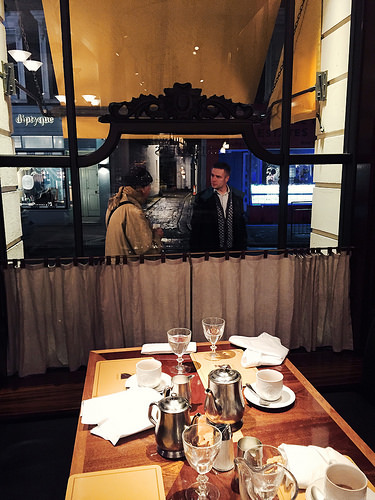<image>
Is the glass behind the teapot? Yes. From this viewpoint, the glass is positioned behind the teapot, with the teapot partially or fully occluding the glass. 